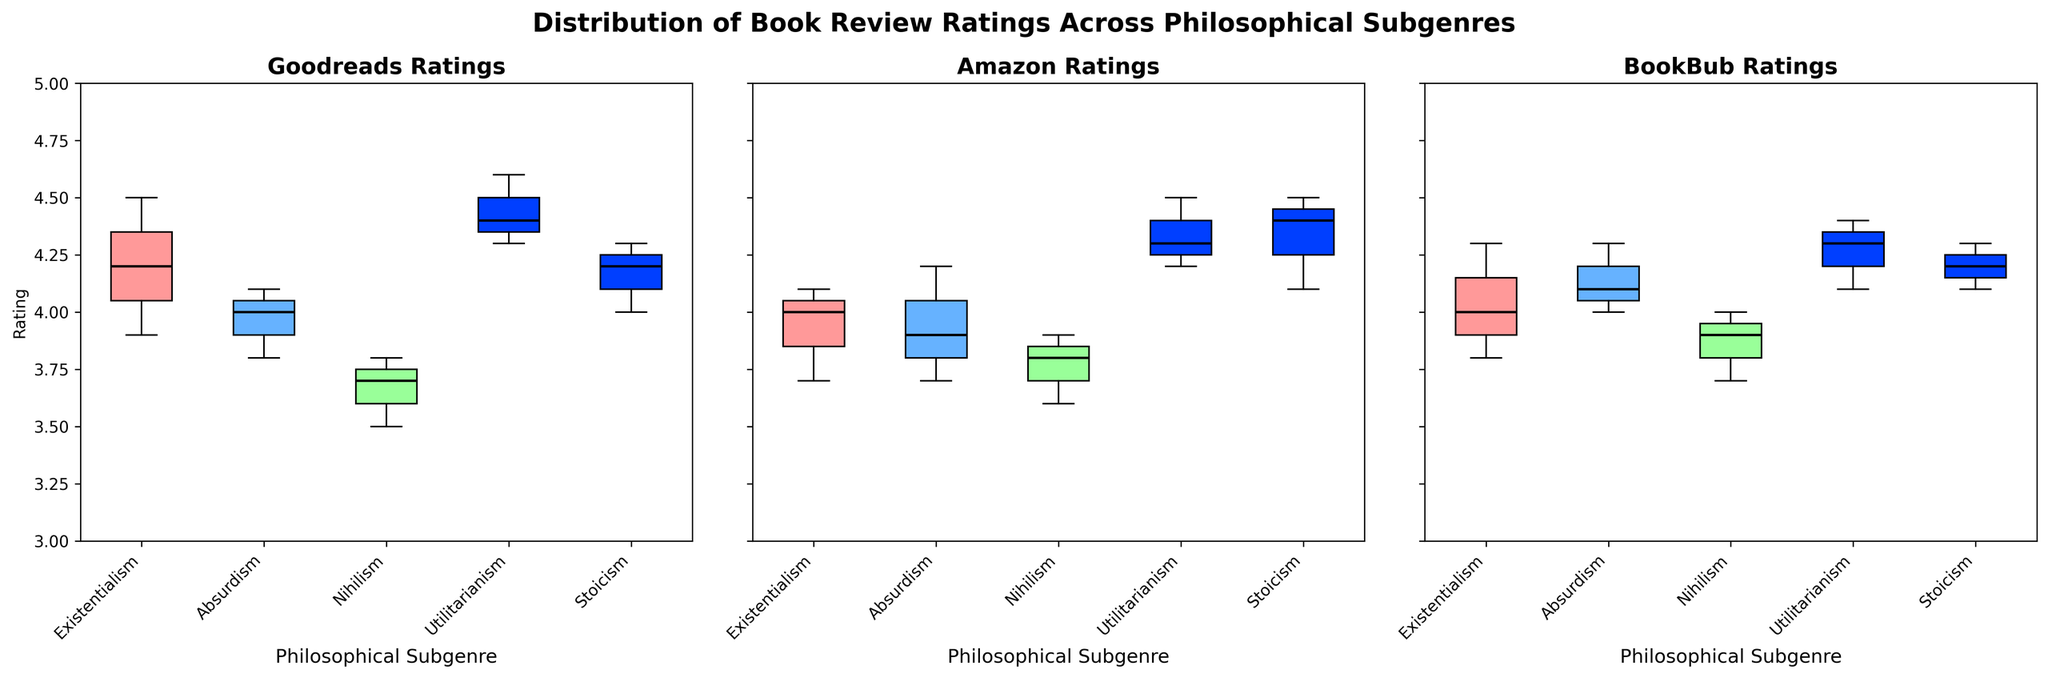Which platform shows the highest median rating for the Existentialism subgenre? Look at the median line within each Existentialism box plot on the three platforms. The highest median line here is on Goodreads.
Answer: Goodreads Which subgenre has the widest range of ratings on Amazon? Examine the range from the bottom whisker to the top whisker of each subgenre's box plot on Amazon. The subgenre Absurdism shows the widest range.
Answer: Absurdism Are the reviews for the Nihilism subgenre more variable on Goodreads or BookBub? Compare the interquartile ranges of the Nihilism subgenre on Goodreads and BookBub. Goodreads has a larger interquartile range, indicating more variability.
Answer: Goodreads Which platform has the most consistent ratings for Stoicism? Consistency in ratings can be inferred by the smallest interquartile range and short whiskers for Stoicism across the platforms. BookBub shows the most consistent ratings.
Answer: BookBub What is the median rating for the Utilitarianism subgenre on Goodreads? The median rating for Utilitarianism on Goodreads is the middle line of the box plot for that subgenre on Goodreads. The median line is at 4.4.
Answer: 4.4 How do the ratings of Utilitarianism compare across the three platforms? Compare the lengths and median lines of the box plots for Utilitarianism across Goodreads, Amazon, and BookBub. Amazon and BookBub have similar medians and spread, while Goodreads has a slightly higher median.
Answer: Similar, but Goodreads slightly higher Which subgenre appears to have the most consistent ratings on Goodreads? The Stoicism subgenre on Goodreads shows a smaller interquartile range and shorter whiskers compared to the other subgenres, indicating more consistent ratings.
Answer: Stoicism How does the variability of ratings for Existentialism on Goodreads compare to those on Amazon? Existentialism on Goodreads and Amazon have similar IQRs, but Goodreads has a slightly shorter overall range (whiskers), indicating marginally less variability.
Answer: Goodreads marginally less Which platform shows the greatest variability in ratings for Absurdism? Check the interquartile range and whiskers for Absurdism on each platform. Amazon shows the greatest variability with the widest range.
Answer: Amazon 